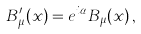<formula> <loc_0><loc_0><loc_500><loc_500>B ^ { \prime } _ { \mu } ( x ) = e ^ { i \alpha } B _ { \mu } ( x ) \, ,</formula> 